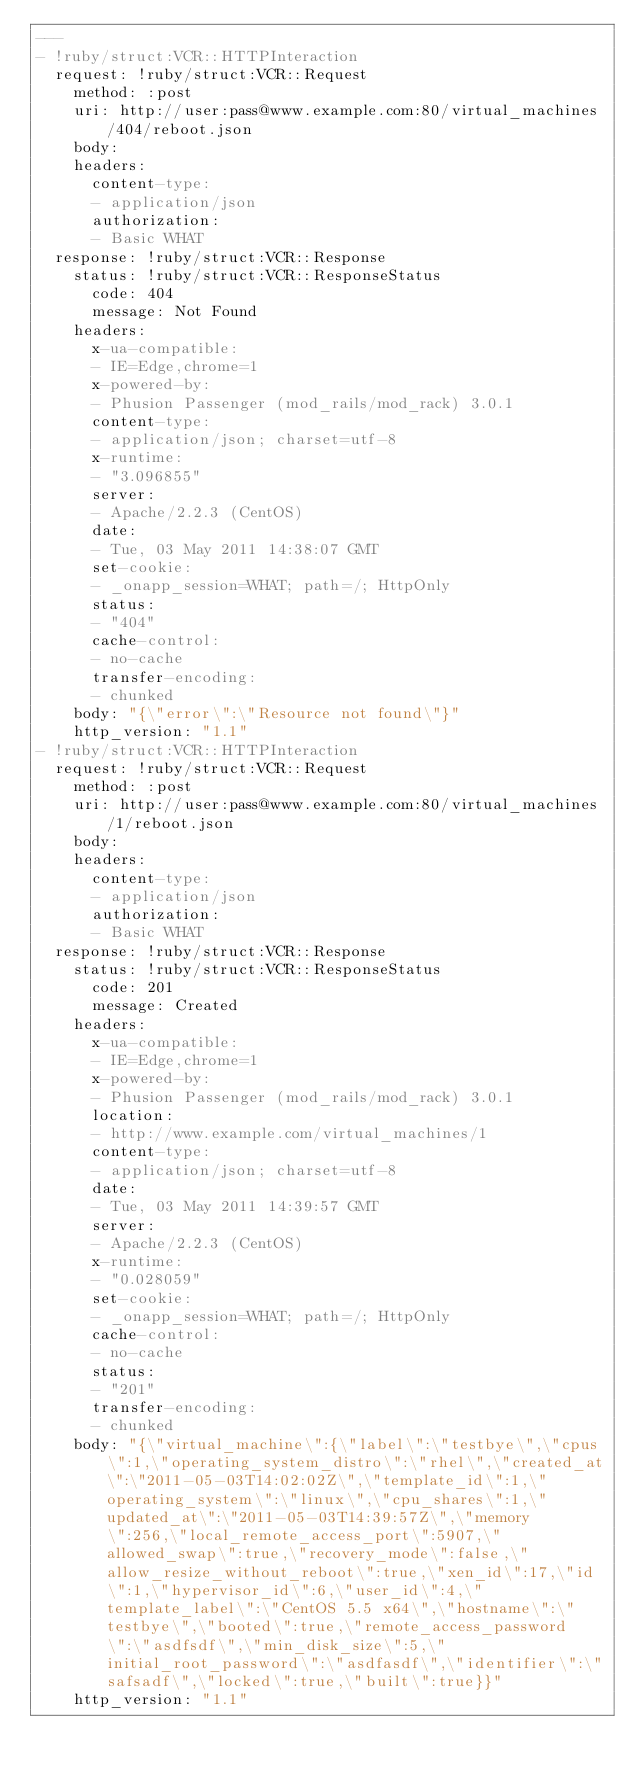Convert code to text. <code><loc_0><loc_0><loc_500><loc_500><_YAML_>--- 
- !ruby/struct:VCR::HTTPInteraction 
  request: !ruby/struct:VCR::Request 
    method: :post
    uri: http://user:pass@www.example.com:80/virtual_machines/404/reboot.json
    body: 
    headers: 
      content-type: 
      - application/json
      authorization: 
      - Basic WHAT
  response: !ruby/struct:VCR::Response 
    status: !ruby/struct:VCR::ResponseStatus 
      code: 404
      message: Not Found
    headers: 
      x-ua-compatible: 
      - IE=Edge,chrome=1
      x-powered-by: 
      - Phusion Passenger (mod_rails/mod_rack) 3.0.1
      content-type: 
      - application/json; charset=utf-8
      x-runtime: 
      - "3.096855"
      server: 
      - Apache/2.2.3 (CentOS)
      date: 
      - Tue, 03 May 2011 14:38:07 GMT
      set-cookie: 
      - _onapp_session=WHAT; path=/; HttpOnly
      status: 
      - "404"
      cache-control: 
      - no-cache
      transfer-encoding: 
      - chunked
    body: "{\"error\":\"Resource not found\"}"
    http_version: "1.1"
- !ruby/struct:VCR::HTTPInteraction 
  request: !ruby/struct:VCR::Request 
    method: :post
    uri: http://user:pass@www.example.com:80/virtual_machines/1/reboot.json
    body: 
    headers: 
      content-type: 
      - application/json
      authorization: 
      - Basic WHAT
  response: !ruby/struct:VCR::Response 
    status: !ruby/struct:VCR::ResponseStatus 
      code: 201
      message: Created
    headers: 
      x-ua-compatible: 
      - IE=Edge,chrome=1
      x-powered-by: 
      - Phusion Passenger (mod_rails/mod_rack) 3.0.1
      location: 
      - http://www.example.com/virtual_machines/1
      content-type: 
      - application/json; charset=utf-8
      date: 
      - Tue, 03 May 2011 14:39:57 GMT
      server: 
      - Apache/2.2.3 (CentOS)
      x-runtime: 
      - "0.028059"
      set-cookie: 
      - _onapp_session=WHAT; path=/; HttpOnly
      cache-control: 
      - no-cache
      status: 
      - "201"
      transfer-encoding: 
      - chunked
    body: "{\"virtual_machine\":{\"label\":\"testbye\",\"cpus\":1,\"operating_system_distro\":\"rhel\",\"created_at\":\"2011-05-03T14:02:02Z\",\"template_id\":1,\"operating_system\":\"linux\",\"cpu_shares\":1,\"updated_at\":\"2011-05-03T14:39:57Z\",\"memory\":256,\"local_remote_access_port\":5907,\"allowed_swap\":true,\"recovery_mode\":false,\"allow_resize_without_reboot\":true,\"xen_id\":17,\"id\":1,\"hypervisor_id\":6,\"user_id\":4,\"template_label\":\"CentOS 5.5 x64\",\"hostname\":\"testbye\",\"booted\":true,\"remote_access_password\":\"asdfsdf\",\"min_disk_size\":5,\"initial_root_password\":\"asdfasdf\",\"identifier\":\"safsadf\",\"locked\":true,\"built\":true}}"
    http_version: "1.1"
</code> 